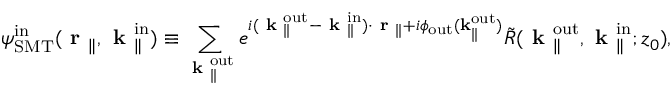Convert formula to latex. <formula><loc_0><loc_0><loc_500><loc_500>{ \psi } _ { S M T } ^ { i n } ( r _ { \| } , k _ { \| } ^ { i n } ) \equiv \sum _ { k _ { \| } ^ { o u t } } e ^ { i ( k _ { \| } ^ { o u t } - k _ { \| } ^ { i n } ) \cdot r _ { \| } + i \phi _ { o u t } ( k _ { \| } ^ { o u t } ) } \tilde { R } ( k _ { \| } ^ { o u t } , k _ { \| } ^ { i n } ; z _ { 0 } ) ,</formula> 